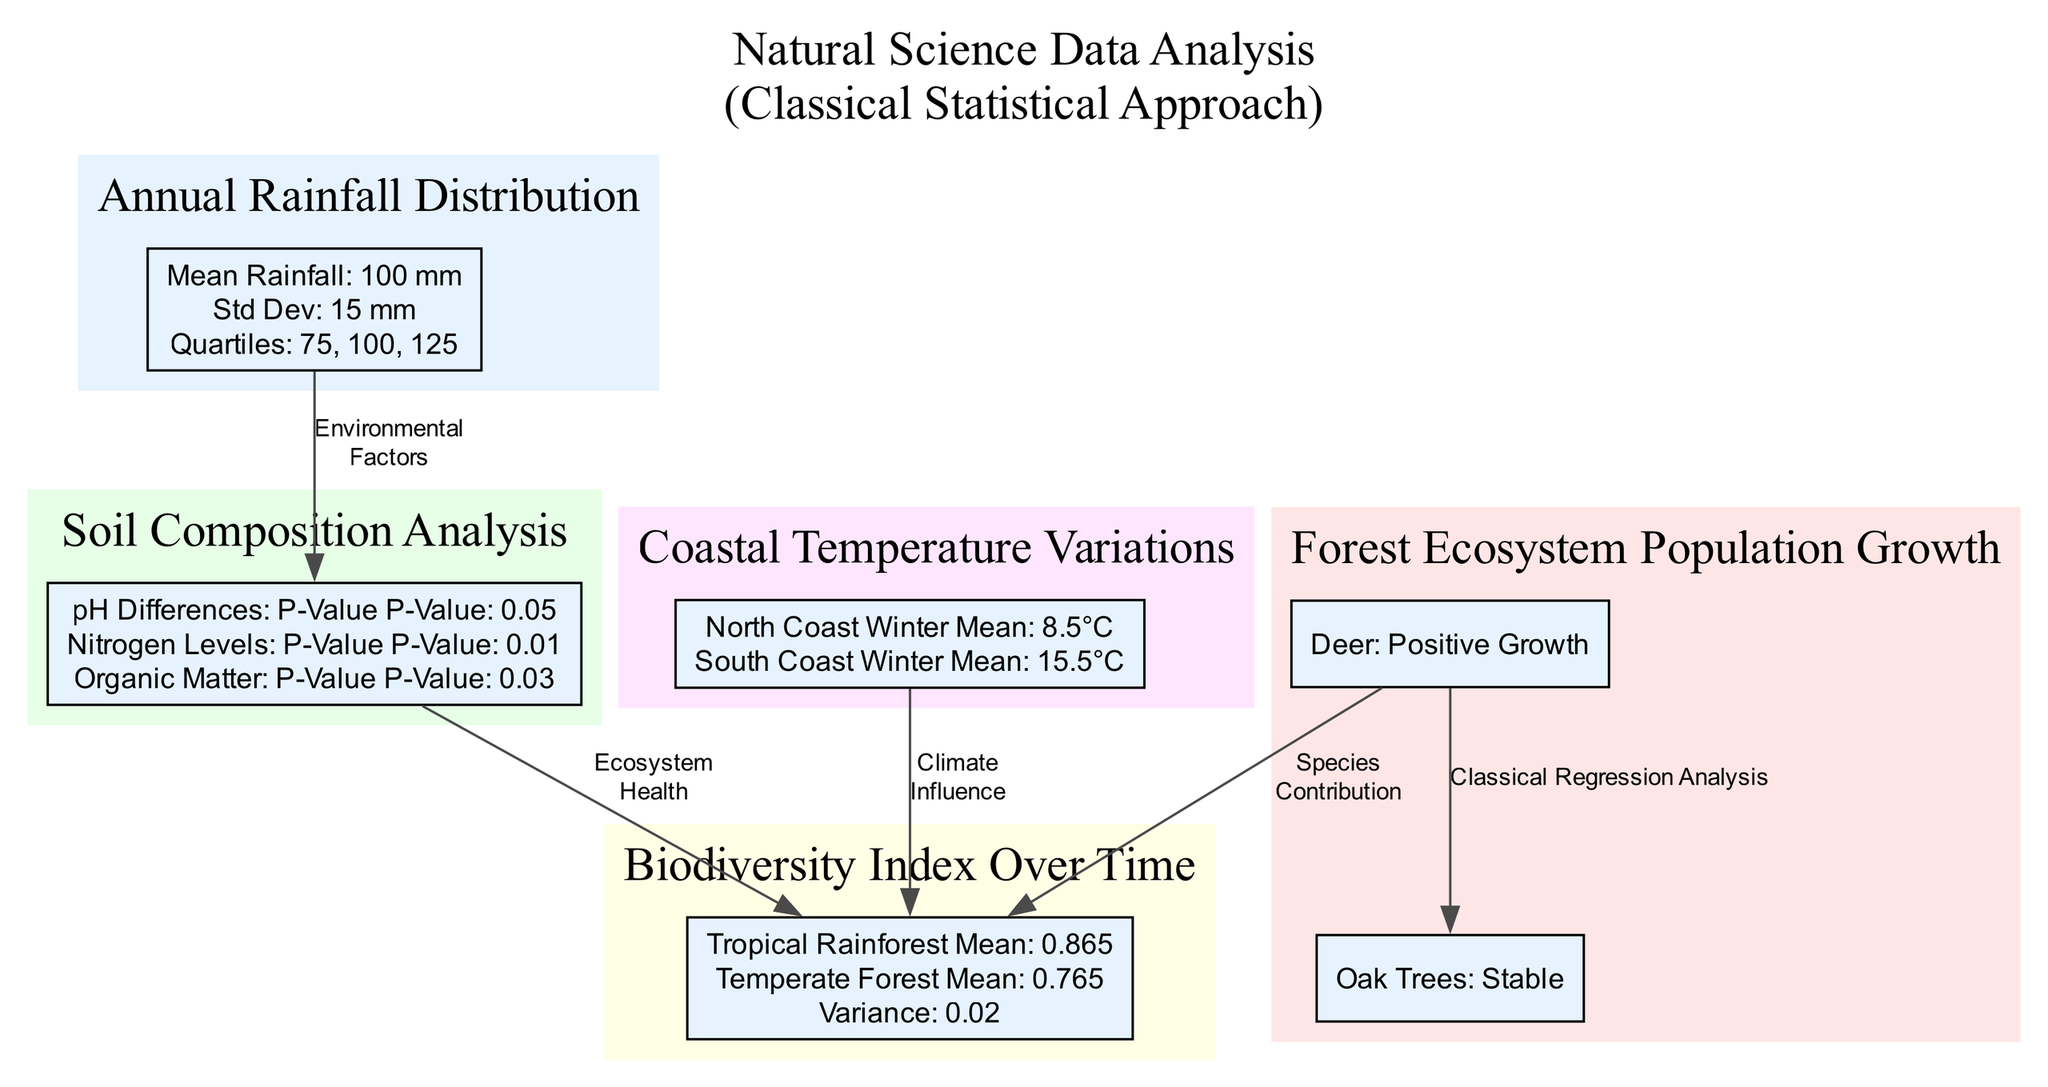What is the mean rainfall for the Annual Rainfall Distribution? The diagram indicates the mean rainfall value for the Annual Rainfall Distribution, which is directly provided in the statistical measures section as 100 mm.
Answer: 100 mm What is the population of Deer in 2022? The Deer population data for 2022 is clearly stated in the Population Growth of a Forest Ecosystem cluster, showing a population of 240 individuals.
Answer: 240 What was the trend line for Oak Trees' population growth? In the Forest Ecosystem Population Growth cluster, the trend line for Oak Trees is labeled as "Flat Slope," indicating minimal change over the observed period.
Answer: Flat Slope What p-value indicates the significance of Nitrogen Levels? The Soil Composition Analysis cluster contains a section on statistical significance tests, where the p-value for Nitrogen Levels is stated as 0.01.
Answer: 0.01 What is the variance of the Biodiversity Index? The statistical measures for the Biodiversity Index Over Time include the variance, which is specifically stated as 0.02 in the diagram.
Answer: 0.02 How do seasonal anomalies affect the North Coast? The diagram notes a specific seasonal anomaly for the North Coast in December, with a temperature anomaly of -2 degrees Celsius, indicating a drop below the expected temperature.
Answer: -2 Which ecosystem showed the highest mean biodiversity index? Comparing the ecosystems provided in the Biodiversity Index Over Time cluster, the Tropical Rainforest has the highest mean biodiversity index of 0.865.
Answer: 0.865 What is the relationship between rainfall and biodiversity in the diagram? The diagram illustrates a flow where the rainfall impact connects to the soil composition, leading to an influence on biodiversity, suggesting that environmental factors (like rainfall) significantly affect ecosystem health.
Answer: Environmental Factors How has the population of Oak Trees changed from 2012 to 2022? The change in the population of Oak Trees is reflected in the data showing a population growth from 300 to 310 from 2012 to 2022, indicating stability over the decade.
Answer: Stable 